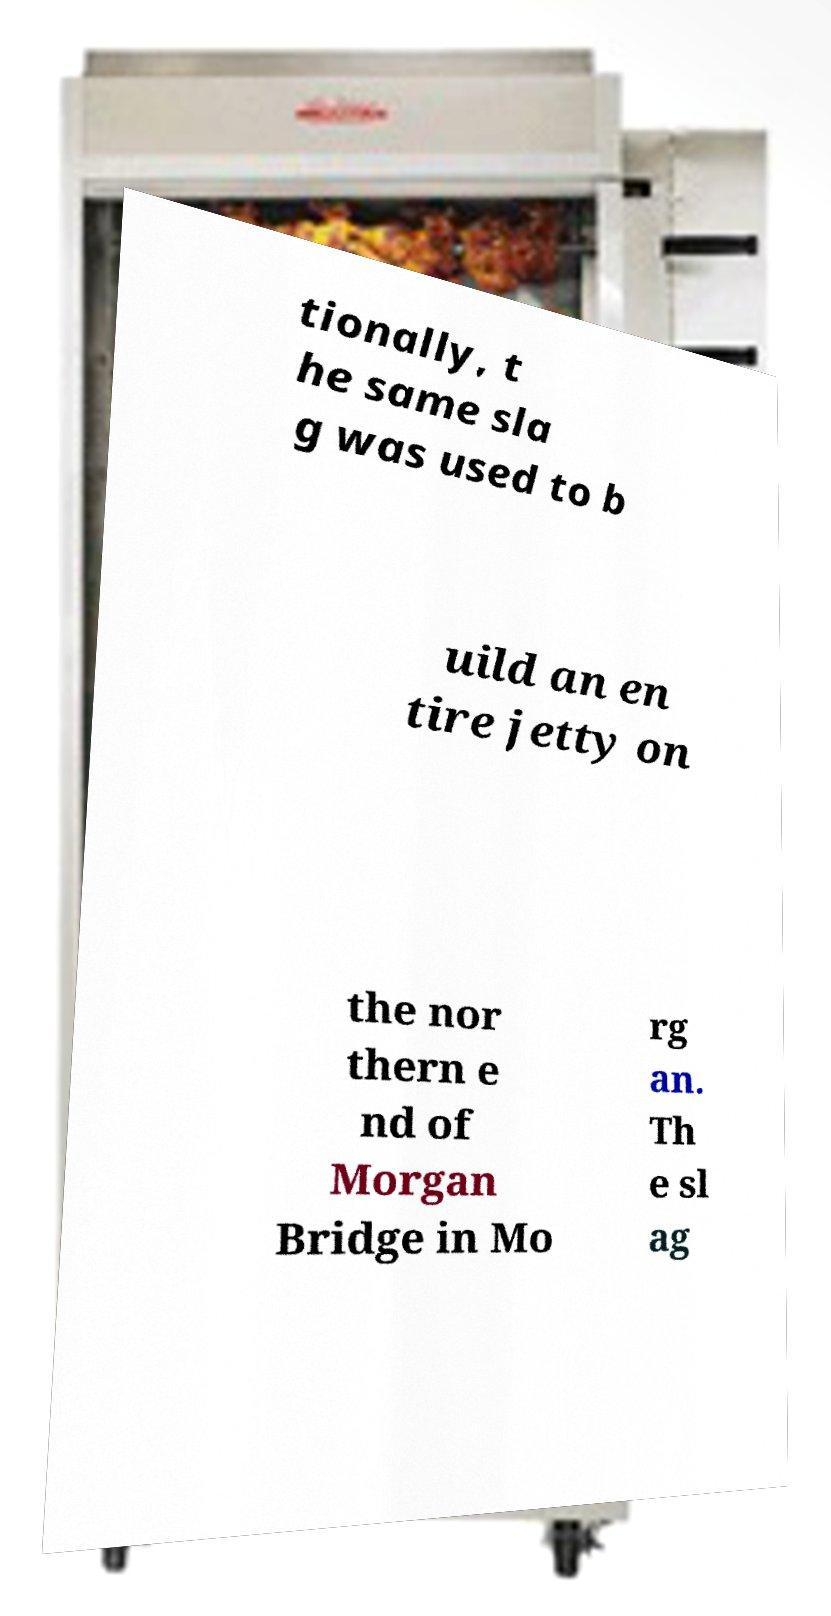For documentation purposes, I need the text within this image transcribed. Could you provide that? tionally, t he same sla g was used to b uild an en tire jetty on the nor thern e nd of Morgan Bridge in Mo rg an. Th e sl ag 